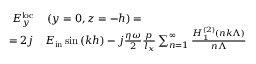<formula> <loc_0><loc_0><loc_500><loc_500>\begin{array} { r l } { E _ { y } ^ { l o c } } & \left ( y = 0 , z = - h \right ) = } \\ { = 2 j } & E _ { i n } \sin { \left ( k h \right ) } - j \frac { \eta \omega } { 2 } \frac { p } { l _ { x } } \sum _ { n = 1 } ^ { \infty } \frac { H _ { 1 } ^ { \left ( 2 \right ) } \left ( n k \Lambda \right ) } { n \Lambda } } \end{array}</formula> 